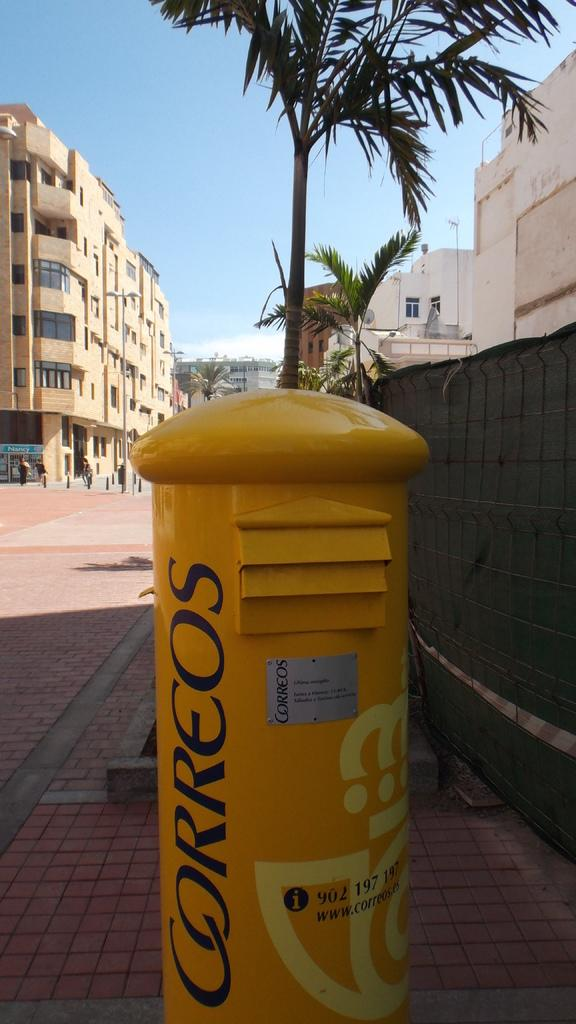<image>
Share a concise interpretation of the image provided. A tall yellow container with the word Correos on it. 